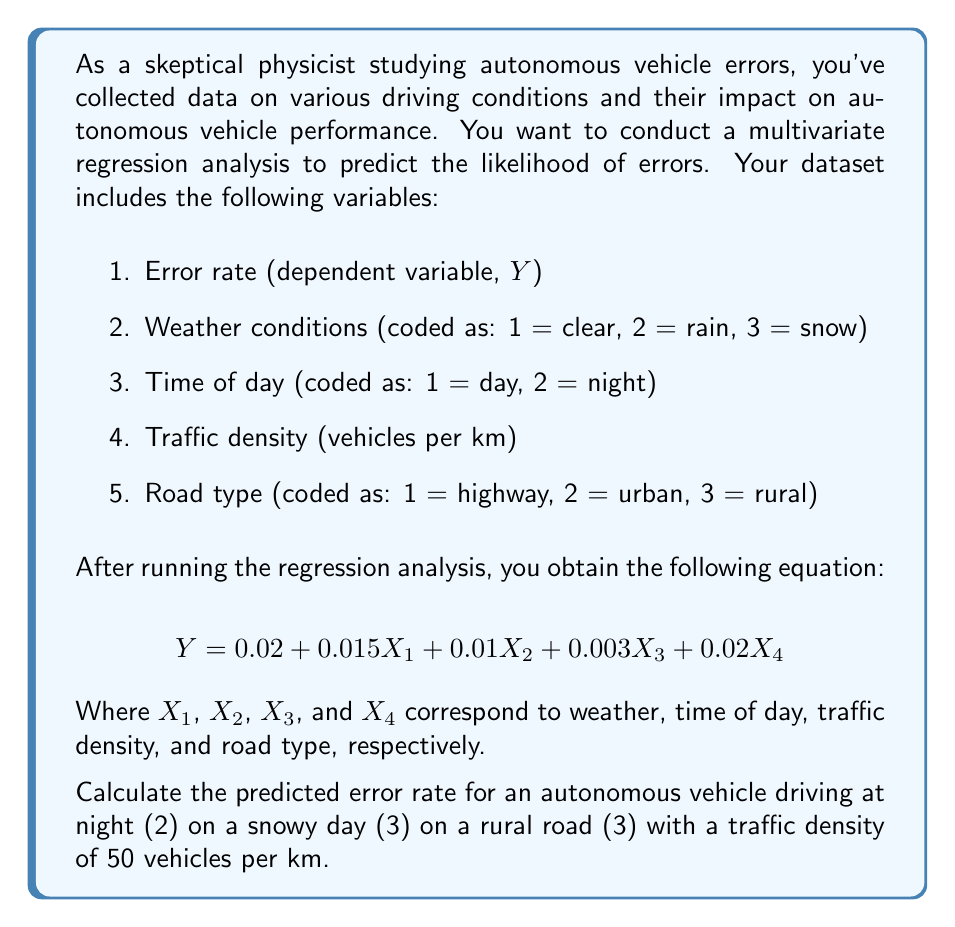Provide a solution to this math problem. To solve this problem, we need to use the given multivariate regression equation and substitute the values for each variable:

$$ Y = 0.02 + 0.015X_1 + 0.01X_2 + 0.003X_3 + 0.02X_4 $$

Let's substitute the values:

1. $X_1$ (Weather) = 3 (snow)
2. $X_2$ (Time of day) = 2 (night)
3. $X_3$ (Traffic density) = 50 vehicles per km
4. $X_4$ (Road type) = 3 (rural)

Now, let's calculate step by step:

1. Constant term: 0.02

2. Weather term: $0.015 \times 3 = 0.045$

3. Time of day term: $0.01 \times 2 = 0.02$

4. Traffic density term: $0.003 \times 50 = 0.15$

5. Road type term: $0.02 \times 3 = 0.06$

Now, we sum all these terms:

$$ Y = 0.02 + 0.045 + 0.02 + 0.15 + 0.06 $$

$$ Y = 0.295 $$

Therefore, the predicted error rate is 0.295 or 29.5%.
Answer: The predicted error rate is 0.295 or 29.5%. 